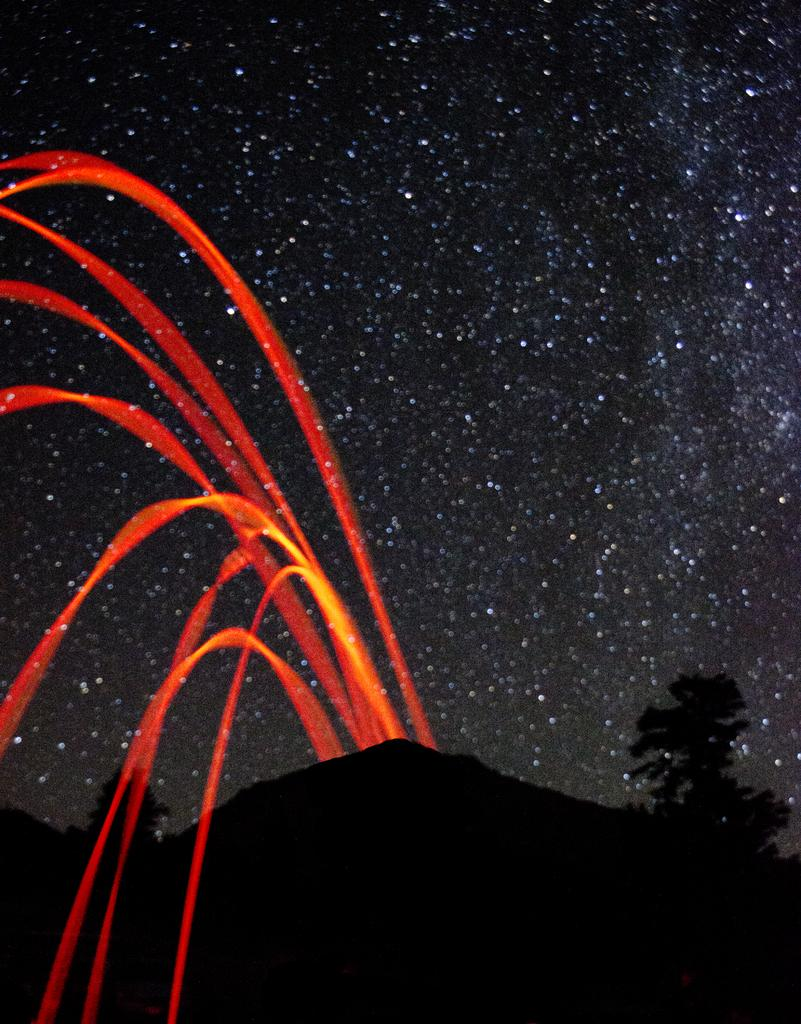What time of day is depicted in the image? The image depicts a night view. What can be seen illuminated in the image? There are lights visible in the image. What type of natural landscape is present in the image? There are mountains and trees in the image. What celestial bodies can be seen in the sky in the image? Stars are visible in the sky in the image. What type of news can be heard being reported in the image? There is no audio or news reporting present in the image; it is a visual representation of a night view with lights, mountains, trees, and stars. What rhythm is being played by the trees in the image? There is no rhythm being played by the trees in the image; they are stationary natural elements. 